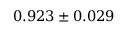Convert formula to latex. <formula><loc_0><loc_0><loc_500><loc_500>0 . 9 2 3 \pm 0 . 0 2 9</formula> 